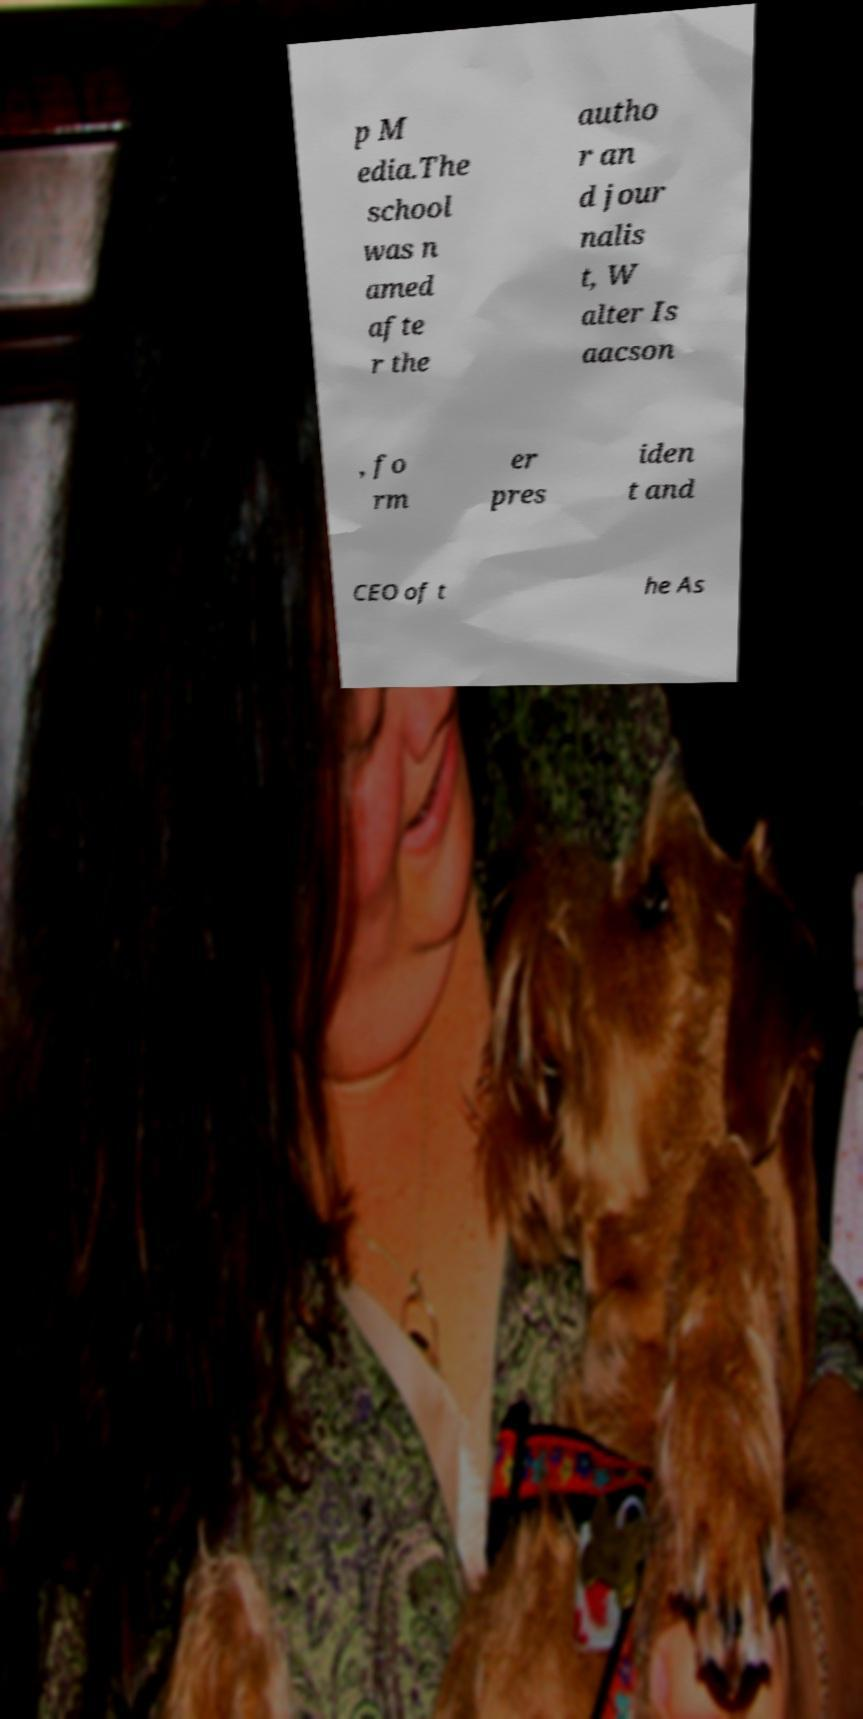Can you read and provide the text displayed in the image?This photo seems to have some interesting text. Can you extract and type it out for me? p M edia.The school was n amed afte r the autho r an d jour nalis t, W alter Is aacson , fo rm er pres iden t and CEO of t he As 